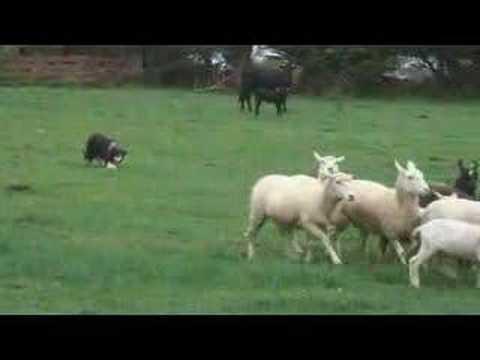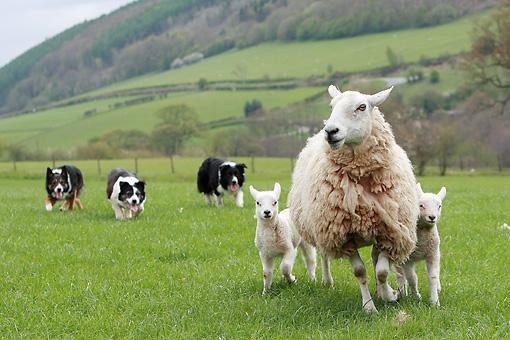The first image is the image on the left, the second image is the image on the right. For the images displayed, is the sentence "There are three sheeps and one dog in one of the images." factually correct? Answer yes or no. No. The first image is the image on the left, the second image is the image on the right. Given the left and right images, does the statement "The dog in the image on the left is rounding up cattle." hold true? Answer yes or no. No. 